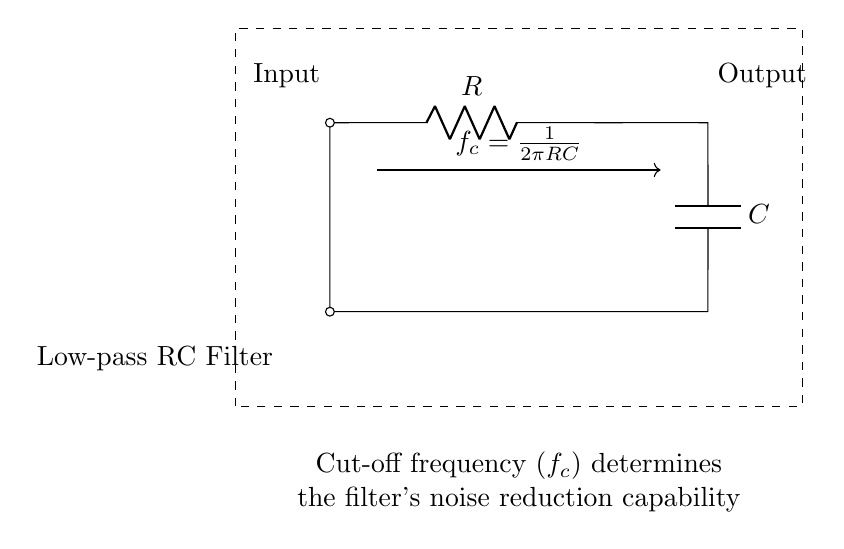What components are used in this circuit? The components in the circuit are a resistor (R) and a capacitor (C). The circuit diagram clearly labels both components, making it easy to identify them.
Answer: Resistor and Capacitor What type of filter is represented in this circuit? The circuit is a low-pass filter, which is indicated by the label "Low-pass RC Filter" within the diagram. This filter allows low-frequency signals to pass while attenuating higher frequencies.
Answer: Low-pass filter What is the input to the circuit? The input to the circuit is noted as "Input" on the left side of the diagram, indicating where the signal is applied to the filter.
Answer: Input What is the output of the circuit? The output of the circuit is labeled as "Output" on the right side of the diagram, showing where the filtered signal can be obtained.
Answer: Output What does the acronym "fc" represent in this circuit? The acronym "fc" represents the cut-off frequency, which is defined as the frequency at which the output signal begins to attenuate significantly. The formula given in the diagram explicitly shows how it is calculated.
Answer: Cut-off frequency What is the relationship between the cut-off frequency and the resistance and capacitance values? The cut-off frequency is inversely proportional to the product of the resistance and capacitance, as indicated by the formula in the diagram, which states f_c = 1/(2πRC). This means that increasing either R or C decreases fc, resulting in a lower cut-off frequency.
Answer: Inversely proportional How does this circuit reduce noise in audio systems? This RC low-pass filter reduces noise by allowing only low-frequency signals to pass and attenuating high-frequency noise that can disrupt audio clarity. The cut-off frequency determines which frequencies are effectively passed.
Answer: Reduces high-frequency noise 